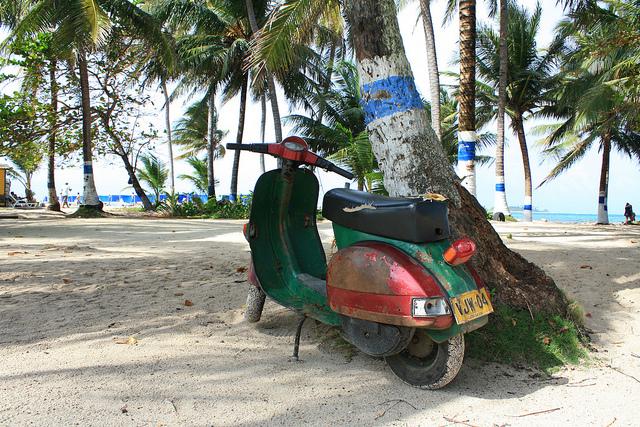What color is the moped?
Keep it brief. Green. Are the palm tree trunks painted?
Short answer required. Yes. What is happening?
Keep it brief. Nothing. 